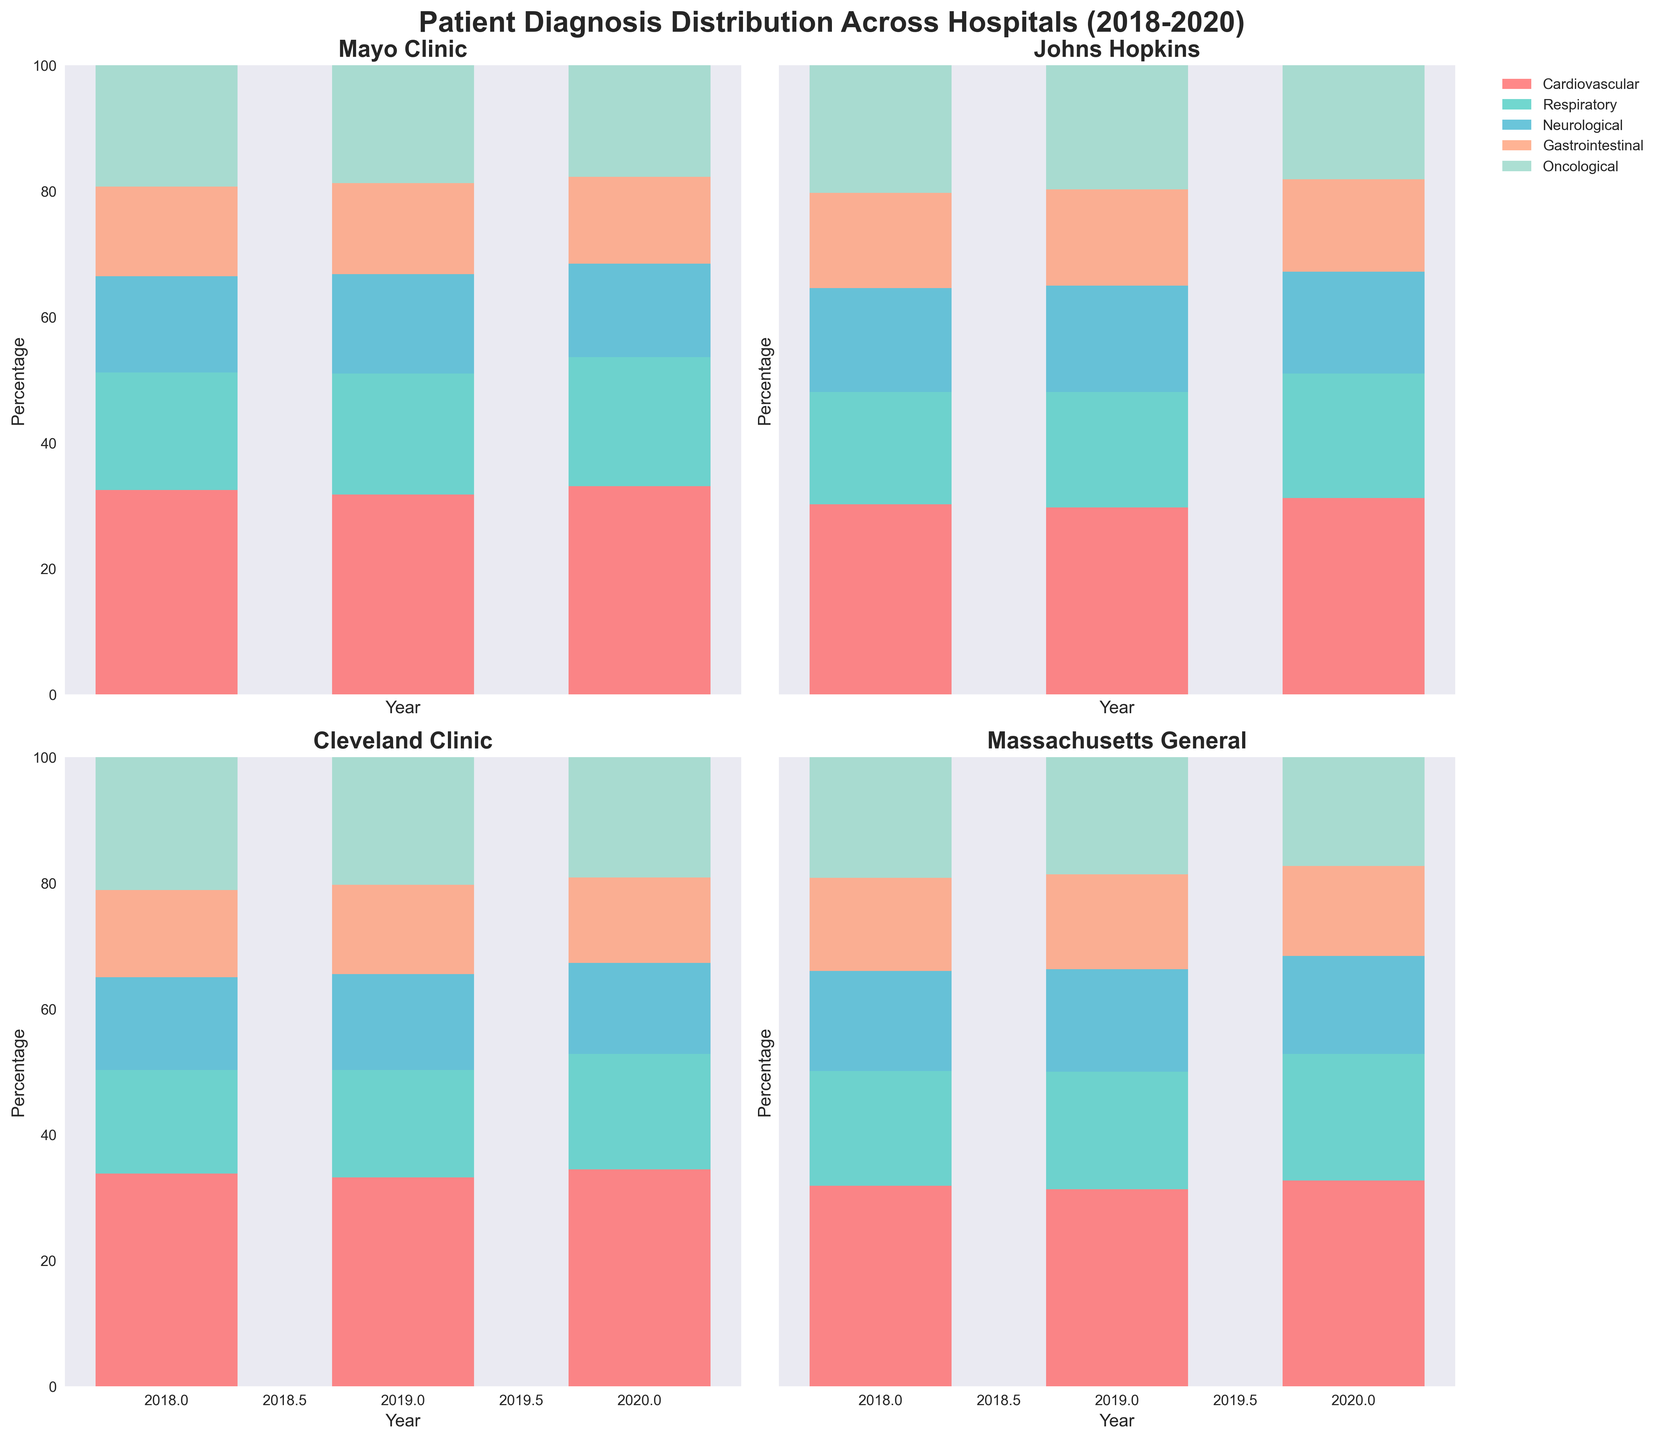what is the title of the chart? The title of the chart is usually displayed at the top center of the figure. Based on the provided code, the title is 'Patient Diagnosis Distribution Across Hospitals (2018-2020)'.
Answer: Patient Diagnosis Distribution Across Hospitals (2018-2020) How many hospitals are compared in the figure? The figure contains subplots for each hospital. Referring to the dataset and code, 4 hospitals are being compared: Mayo Clinic, Johns Hopkins, Cleveland Clinic, and Massachusetts General.
Answer: 4 Which hospital had the highest percentage of Cardiovascular diagnoses in 2020? Look at the bar heights for the Cardiovascular category in 2020 across all hospital subplots. Cleveland Clinic had the highest cardiovascular percentage at 34.5%.
Answer: Cleveland Clinic Across all hospitals, which diagnosis showed a decreasing trend from 2018 to 2020? Examine the trend lines for each diagnosis category in each subplot. The Oncological diagnoses showed a decreasing trend across all hospitals from 2018 to 2020.
Answer: Oncological What is the total percentage of Respiratory and Neurological diagnoses at Mayo Clinic in 2019? Sum the percentages of Respiratory (19.2) and Neurological (15.8) diagnoses at Mayo Clinic in 2019: 19.2 + 15.8 = 35.
Answer: 35 Which diagnosis category saw the highest percentage increase in Mayo Clinic from 2018 to 2020? Compare the 2018 and 2020 values for each category at Mayo Clinic subplot. Cardiovascular showed an increase from 32.5% to 33.1%, Respiratory from 18.7% to 20.5%, Neurological decreased, Gastrointestinal decreased, Oncological decreased. Respiratory saw the highest increase: 20.5 - 18.7 = 1.8.
Answer: Respiratory Which hospital had the lowest percentage of Gastrointestinal diagnoses in 2020? Look at the Gastrointestinal values in 2020 in each subplot. Cleveland Clinic had the lowest percentage of Gastrointestinal diagnoses in 2020 with 13.6%.
Answer: Cleveland Clinic In 2020, which hospital had the highest percentage of Oncological diagnoses? Examine the bar heights for Oncological in 2020 for each hospital. Mayo Clinic had the highest percentage of Oncological diagnoses in 2020 with 17.7%.
Answer: Mayo Clinic How did the percentage of Respiratory diagnoses at Johns Hopkins change from 2018 to 2020? Track the values for Respiratory diagnoses in 2018, 2019, and 2020 for Johns Hopkins. They increased from 17.9% in 2018 to 19.8% in 2020.
Answer: Increased In which year did Massachusetts General have the highest total percentage of Cardiovascular and Oncological diagnoses combined? Calculate the sum of Cardiovascular and Oncological percentages for each year: 2018 (31.9+19.2=51.1), 2019 (31.3+18.6=49.9), and 2020 (32.7+17.3=50). Thus, 2018 had the highest combined percentage of 51.1.
Answer: 2018 